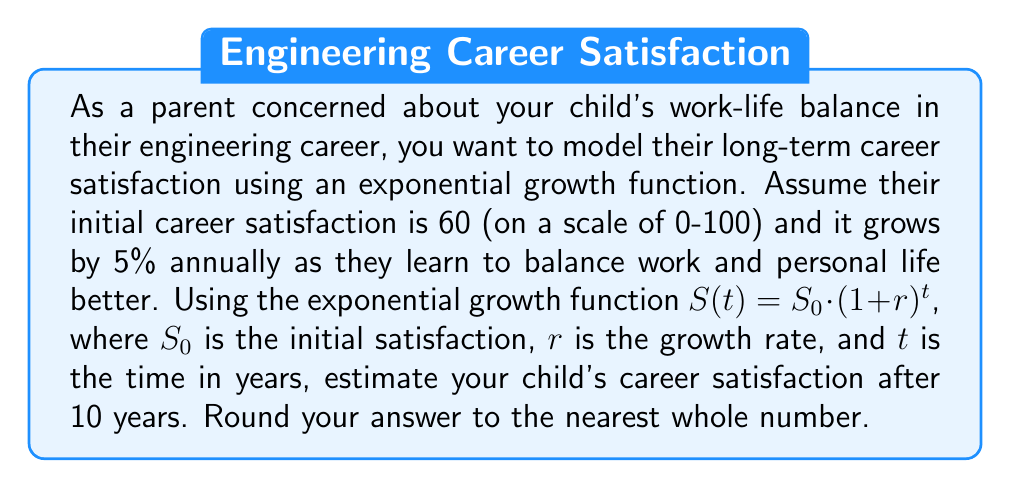Could you help me with this problem? To solve this problem, we'll use the exponential growth function:

$$S(t) = S_0 \cdot (1 + r)^t$$

Where:
$S(t)$ = Career satisfaction after $t$ years
$S_0$ = Initial career satisfaction = 60
$r$ = Annual growth rate = 5% = 0.05
$t$ = Time in years = 10

Let's substitute these values into the equation:

$$S(10) = 60 \cdot (1 + 0.05)^{10}$$

Now, let's calculate step by step:

1. Calculate $(1 + 0.05)^{10}$:
   $(1.05)^{10} \approx 1.6288946$

2. Multiply the result by the initial satisfaction:
   $60 \cdot 1.6288946 \approx 97.73368$

3. Round to the nearest whole number:
   $97.73368 \approx 98$

Therefore, the estimated career satisfaction after 10 years is 98 (on a scale of 0-100).
Answer: 98 